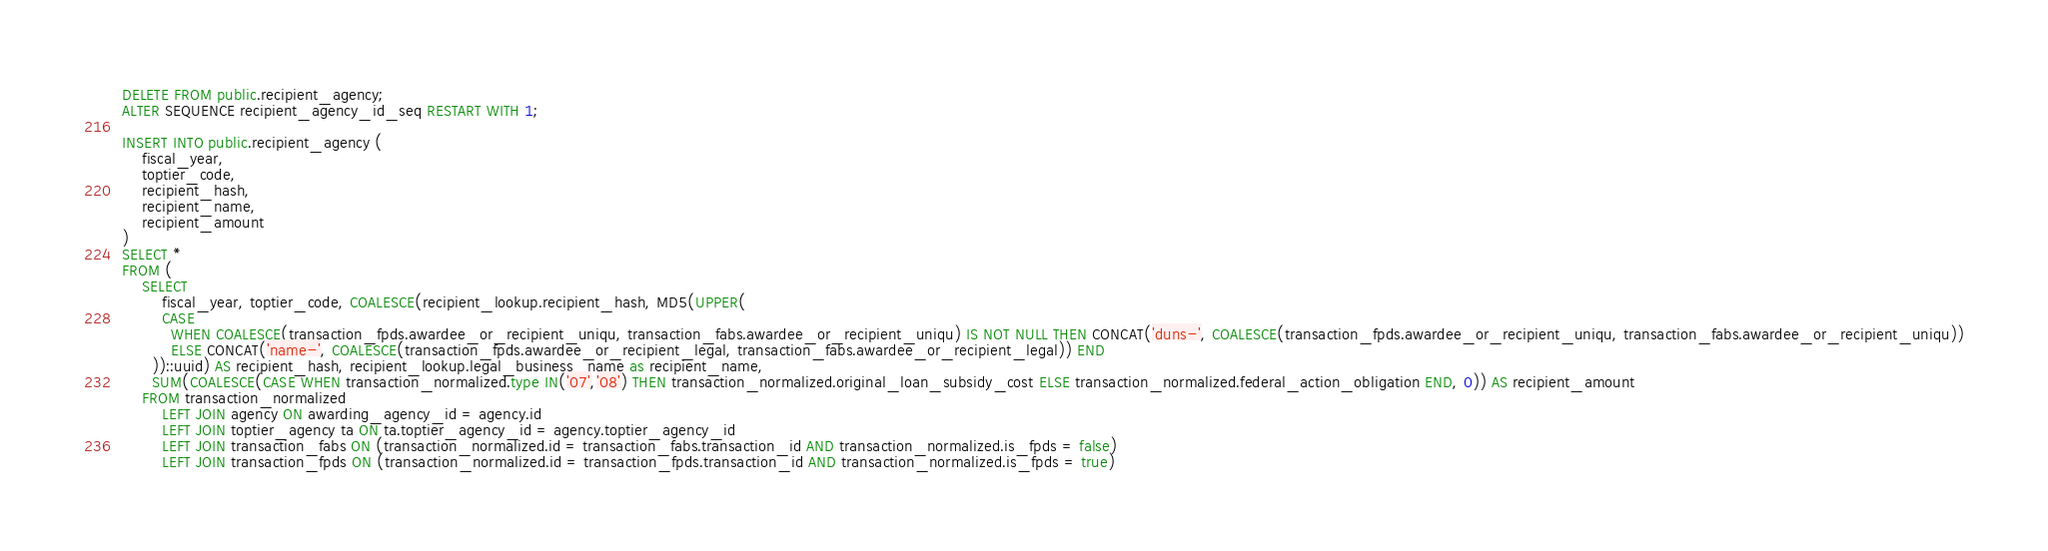Convert code to text. <code><loc_0><loc_0><loc_500><loc_500><_SQL_>DELETE FROM public.recipient_agency;
ALTER SEQUENCE recipient_agency_id_seq RESTART WITH 1;

INSERT INTO public.recipient_agency (
    fiscal_year,
    toptier_code,
    recipient_hash,
    recipient_name,
    recipient_amount
)
SELECT *
FROM (
	SELECT
		fiscal_year, toptier_code, COALESCE(recipient_lookup.recipient_hash, MD5(UPPER(
        CASE
          WHEN COALESCE(transaction_fpds.awardee_or_recipient_uniqu, transaction_fabs.awardee_or_recipient_uniqu) IS NOT NULL THEN CONCAT('duns-', COALESCE(transaction_fpds.awardee_or_recipient_uniqu, transaction_fabs.awardee_or_recipient_uniqu))
          ELSE CONCAT('name-', COALESCE(transaction_fpds.awardee_or_recipient_legal, transaction_fabs.awardee_or_recipient_legal)) END
      ))::uuid) AS recipient_hash, recipient_lookup.legal_business_name as recipient_name,
      SUM(COALESCE(CASE WHEN transaction_normalized.type IN('07','08') THEN transaction_normalized.original_loan_subsidy_cost ELSE transaction_normalized.federal_action_obligation END, 0)) AS recipient_amount
	FROM transaction_normalized
		LEFT JOIN agency ON awarding_agency_id = agency.id
		LEFT JOIN toptier_agency ta ON ta.toptier_agency_id = agency.toptier_agency_id
		LEFT JOIN transaction_fabs ON (transaction_normalized.id = transaction_fabs.transaction_id AND transaction_normalized.is_fpds = false)
		LEFT JOIN transaction_fpds ON (transaction_normalized.id = transaction_fpds.transaction_id AND transaction_normalized.is_fpds = true)</code> 